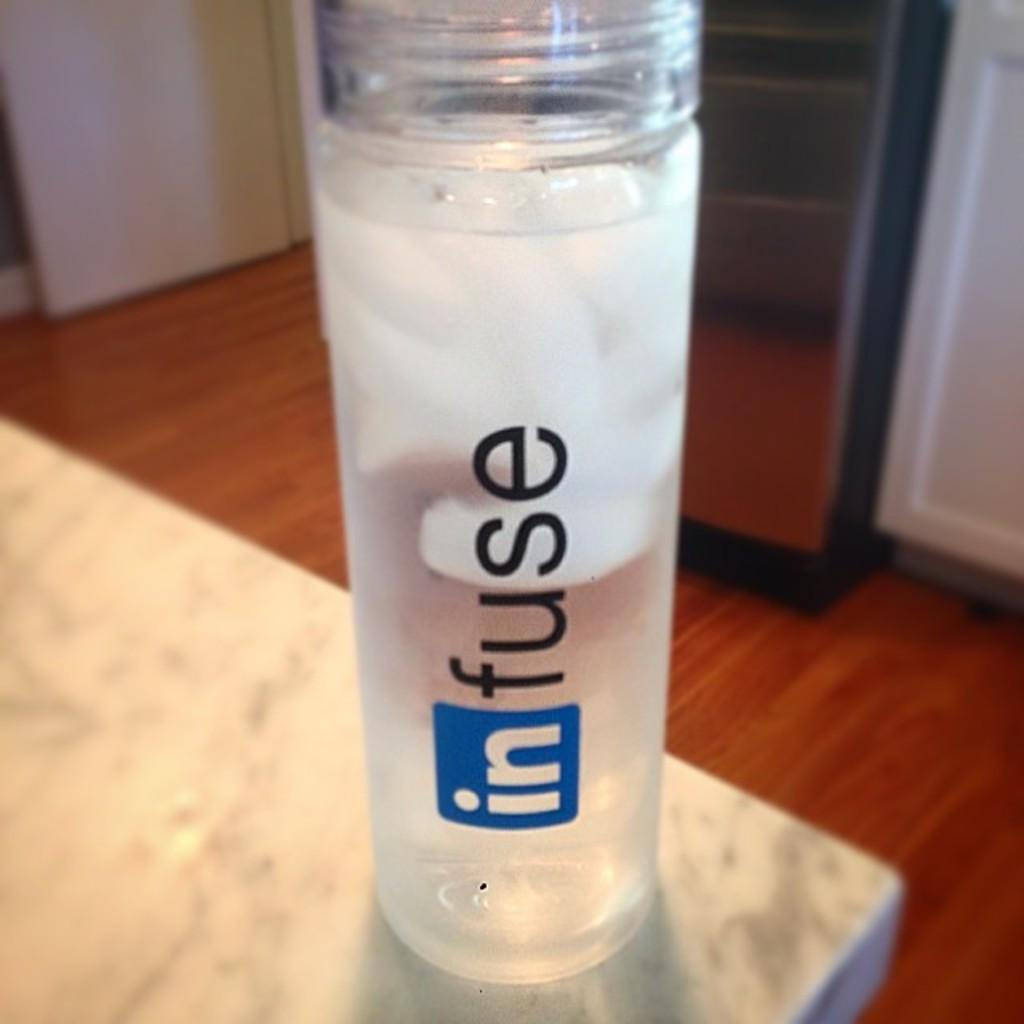What is the main object in the image? There is a bottle in the image. What color is the surface the bottle is on? The bottle is on a white color surface. What can be seen in the background of the image? There are objects on a brown color surface in the background. How much payment is required for the cheese in the image? There is no cheese present in the image, so payment is not applicable. 